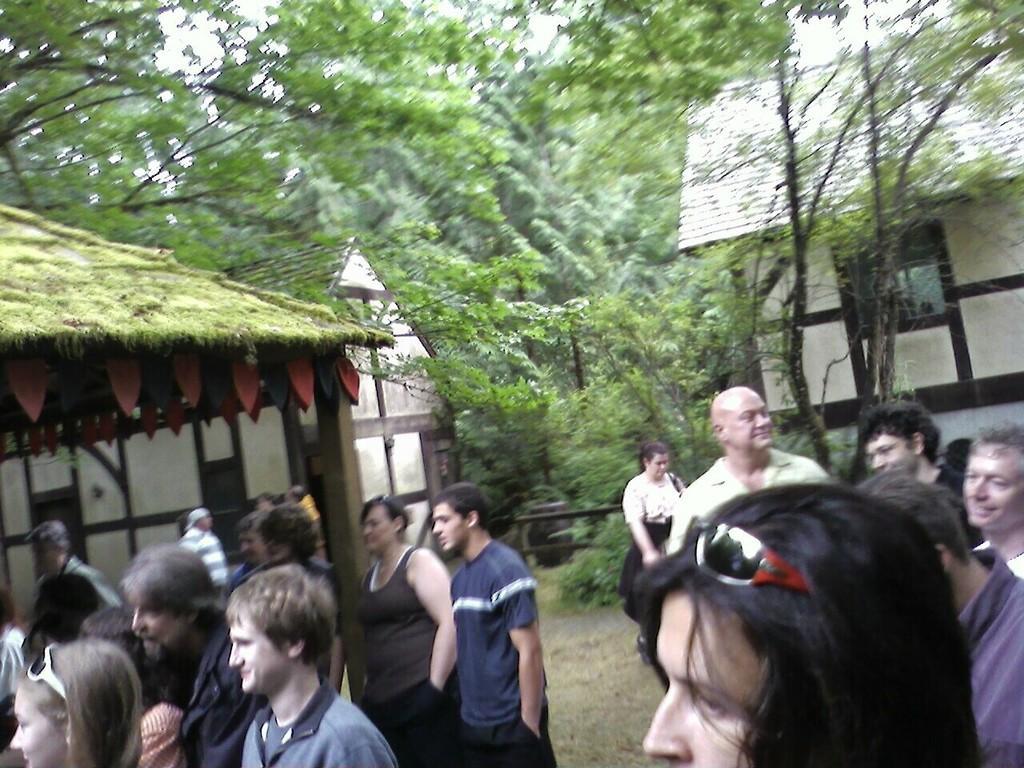Can you describe this image briefly? In this image I can see a group of people are standing on the ground and buildings. In the background I can see trees, plants, window and the sky. This image is taken may be during a day. 